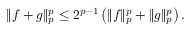Convert formula to latex. <formula><loc_0><loc_0><loc_500><loc_500>\| f + g \| _ { p } ^ { p } \leq 2 ^ { p - 1 } \left ( \| f \| _ { p } ^ { p } + \| g \| _ { p } ^ { p } \right ) .</formula> 